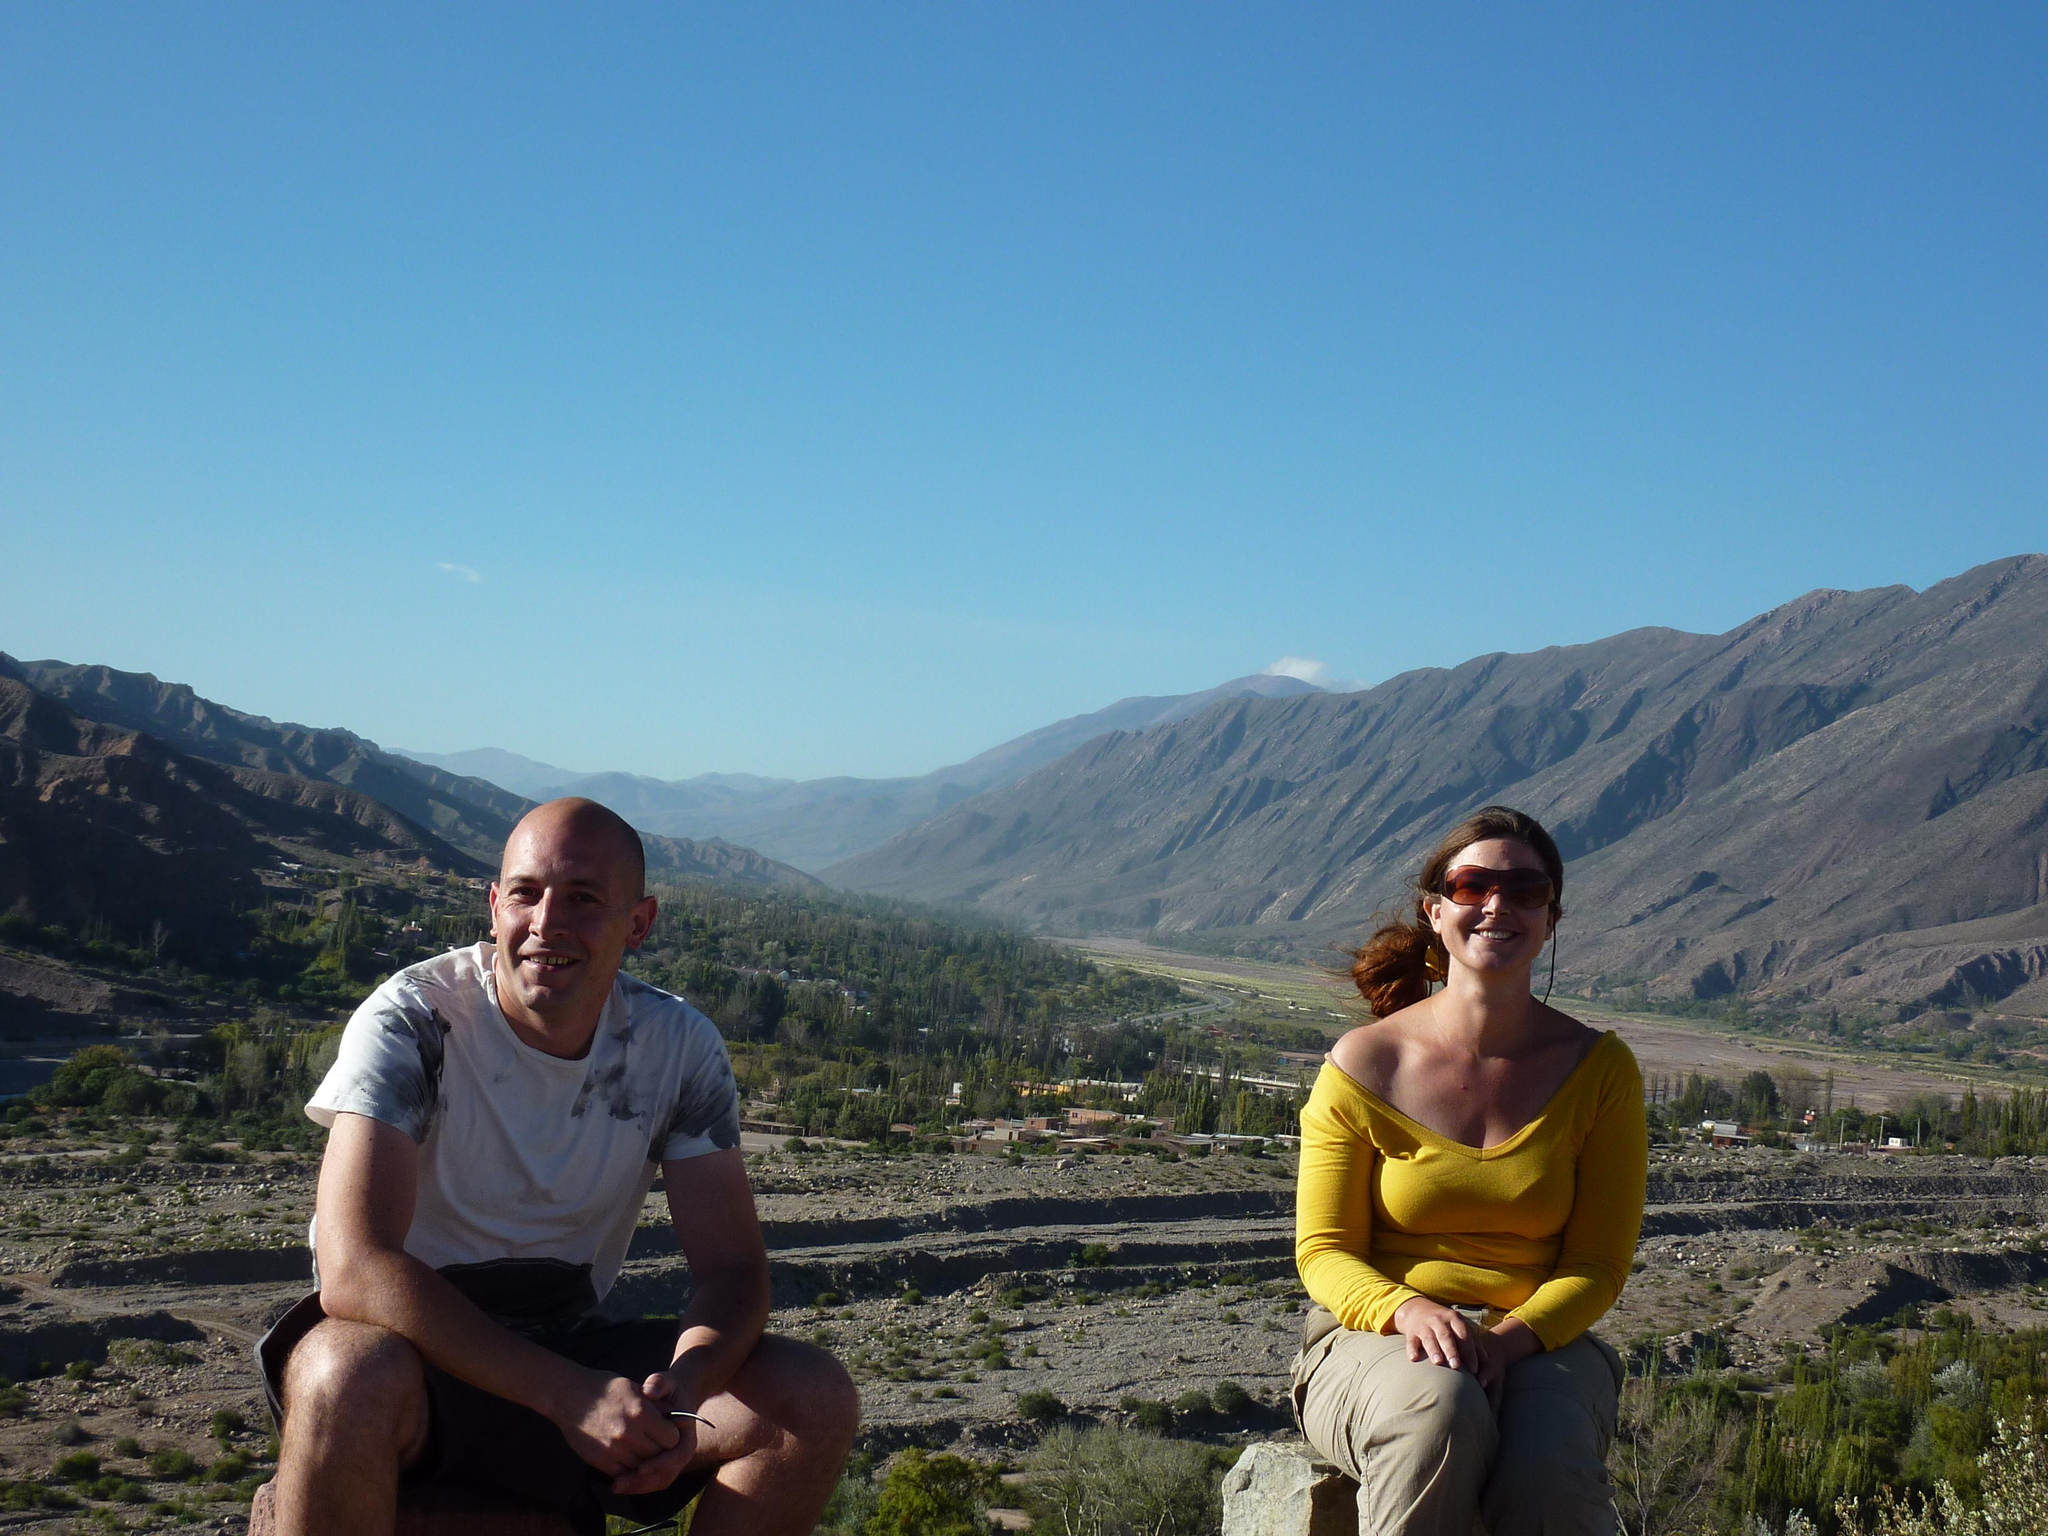How many people are in the image? There are two people in the image, a woman and a man. What are the woman and man doing in the image? The woman and man are sitting and watching something while smiling. What can be seen in the background of the image? There are trees, houseplants, hills, and the sky visible in the background of the image. What type of glove is the woman wearing in the image? There is no glove visible in the image; the woman is not wearing any gloves. What song is the man singing in the image? There is no indication in the image that the man is singing a song, so it cannot be determined from the picture. 